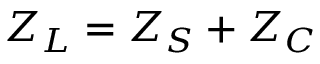<formula> <loc_0><loc_0><loc_500><loc_500>Z _ { L } = Z _ { S } + Z _ { C }</formula> 